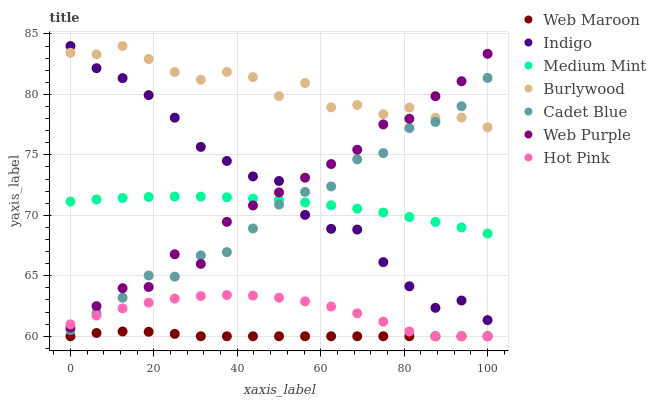Does Web Maroon have the minimum area under the curve?
Answer yes or no. Yes. Does Burlywood have the maximum area under the curve?
Answer yes or no. Yes. Does Cadet Blue have the minimum area under the curve?
Answer yes or no. No. Does Cadet Blue have the maximum area under the curve?
Answer yes or no. No. Is Web Maroon the smoothest?
Answer yes or no. Yes. Is Web Purple the roughest?
Answer yes or no. Yes. Is Cadet Blue the smoothest?
Answer yes or no. No. Is Cadet Blue the roughest?
Answer yes or no. No. Does Hot Pink have the lowest value?
Answer yes or no. Yes. Does Cadet Blue have the lowest value?
Answer yes or no. No. Does Burlywood have the highest value?
Answer yes or no. Yes. Does Cadet Blue have the highest value?
Answer yes or no. No. Is Hot Pink less than Indigo?
Answer yes or no. Yes. Is Cadet Blue greater than Web Maroon?
Answer yes or no. Yes. Does Hot Pink intersect Web Maroon?
Answer yes or no. Yes. Is Hot Pink less than Web Maroon?
Answer yes or no. No. Is Hot Pink greater than Web Maroon?
Answer yes or no. No. Does Hot Pink intersect Indigo?
Answer yes or no. No. 